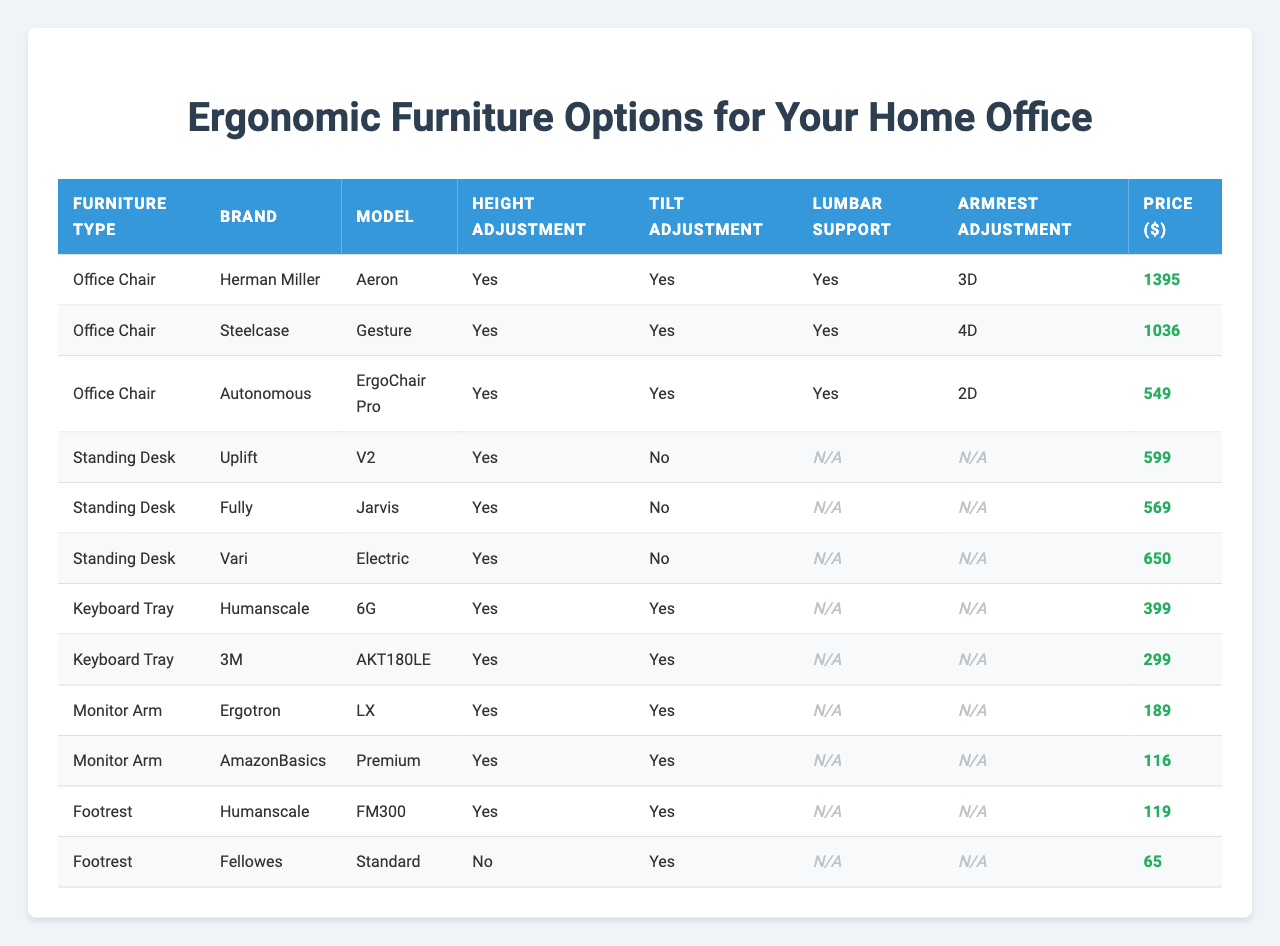What is the price of the Herman Miller Aeron chair? The table lists the price of the Herman Miller Aeron chair in the row corresponding to its details. It states that the price is 1395.
Answer: 1395 How many furniture types in the table have lumbar support? By examining the table, I can see that the furniture types with lumbar support include the Herman Miller Aeron, Steelcase Gesture, Autonomous ErgoChair Pro, and the keyboard trays. Counting these gives a total of 5 items.
Answer: 5 Which brand offers the least expensive office chair? I will look at the prices of the office chairs listed in the table. The Autonomous ErgoChair Pro has a price of 549, which is less than the prices of the other chairs. Therefore, it offers the least expensive option.
Answer: Autonomous Does the Fully jarvis standing desk have a tilt adjustment feature? The table shows that for the Fully Jarvis standing desk, the tilt adjustment feature is marked as "No," indicating it does not have that feature.
Answer: No What is the total price of all standing desks? I will sum the prices of the standing desks in the table: Uplift V2 (599) + Fully Jarvis (569) + Vari Electric (650) equals 1818. Therefore, the total price is 1818.
Answer: 1818 Which office chair has the most adjustment features? I will compare the adjustment features listed for each office chair. The Steelcase Gesture has height adjustment, tilt adjustment, lumbar support, and 4D armrest adjustment, making it the chair with the most adjustment features available.
Answer: Steelcase Gesture Is there an office chair that doesn't have lumbar support? The table presents options for office chairs, and looking for those without lumbar support shows that the Autonomous ErgoChair Pro also has lumbar support. Thus, all listed office chairs include lumbar support.
Answer: No What is the average price of the furniture items that have height adjustment capability? Summing the prices of all furniture items with height adjustment: Herman Miller Aeron (1395) + Steelcase Gesture (1036) + Autonomous ErgoChair Pro (549) + Uplift V2 (599) + Fully Jarvis (569) + Vari Electric (650) + Humanscale 6G (399) + 3M AKT180LE (299) + Ergotron LX (189) + AmazonBasics Premium (116) + Humanscale FM300 (119) gives a total of 6272. There are 11 items; average is 6272/11 ≈ 570.18.
Answer: Approximately 570.18 What furniture type has the lowest price among those with armrest adjustment? I will check the prices of all the items that have armrest adjustment. The cheapest among them is the Herman Miller Aeron at 1395.
Answer: Herman Miller Aeron Which brand has the most offerings in the table? By counting the entries for each brand in the table, I find that both office chairs and standing desks are offered by multiple brands. However, Herman Miller is listed just once, Steelcase is listed once, Autonomous has one chair, and there are several standing desk brands. Overall, I can conclude that no brand has a significantly higher number of offerings than others since each is only listed once per type.
Answer: None 